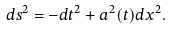Convert formula to latex. <formula><loc_0><loc_0><loc_500><loc_500>d s ^ { 2 } = - d t ^ { 2 } + a ^ { 2 } ( t ) d x ^ { 2 } .</formula> 